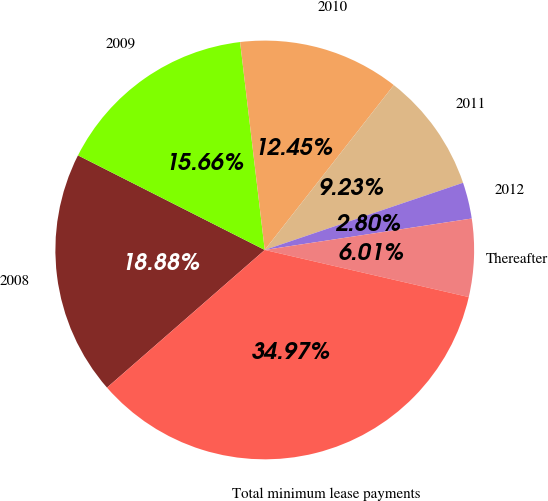<chart> <loc_0><loc_0><loc_500><loc_500><pie_chart><fcel>2008<fcel>2009<fcel>2010<fcel>2011<fcel>2012<fcel>Thereafter<fcel>Total minimum lease payments<nl><fcel>18.88%<fcel>15.66%<fcel>12.45%<fcel>9.23%<fcel>2.8%<fcel>6.01%<fcel>34.97%<nl></chart> 